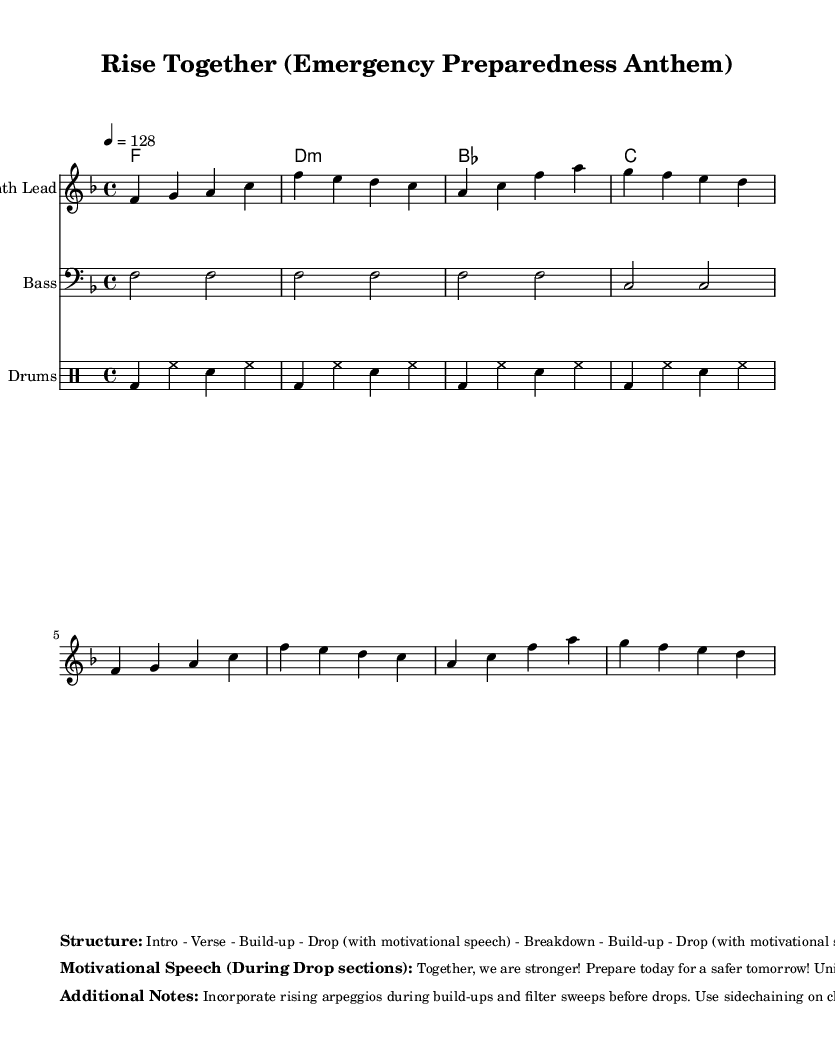What is the key signature of this music? The key signature is F major, indicated by one flat (B♭) in the music sheet.
Answer: F major What is the time signature of this music? The time signature is 4/4, which means there are four beats in each measure and a quarter note receives one beat.
Answer: 4/4 What is the tempo marking for this piece? The tempo marking is 128 beats per minute, as shown in the tempo indication to maintain an upbeat pace.
Answer: 128 Which instrument plays the synth lead? The synth lead is performed by the "Synth Lead" staff indicated in the notation.
Answer: Synth Lead How many drops are indicated in the structure? The structure includes two drops, as stated in the markup section, providing points for motivational speeches in the song.
Answer: 2 What is the theme of the motivational speeches during the drops? The speeches focus on strength and unity in crisis preparedness, emphasizing collective empowerment and resilience.
Answer: Strength and Unity What musical effect is suggested for the buildup sections? The notes suggest incorporating rising arpeggios and filter sweeps during the build-up sections to create tension and anticipation before the drops.
Answer: Rising arpeggios 